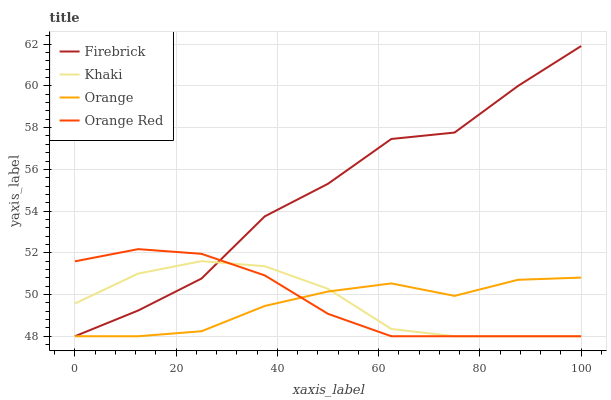Does Orange have the minimum area under the curve?
Answer yes or no. Yes. Does Firebrick have the maximum area under the curve?
Answer yes or no. Yes. Does Khaki have the minimum area under the curve?
Answer yes or no. No. Does Khaki have the maximum area under the curve?
Answer yes or no. No. Is Orange Red the smoothest?
Answer yes or no. Yes. Is Firebrick the roughest?
Answer yes or no. Yes. Is Khaki the smoothest?
Answer yes or no. No. Is Khaki the roughest?
Answer yes or no. No. Does Orange have the lowest value?
Answer yes or no. Yes. Does Firebrick have the highest value?
Answer yes or no. Yes. Does Khaki have the highest value?
Answer yes or no. No. Does Firebrick intersect Orange?
Answer yes or no. Yes. Is Firebrick less than Orange?
Answer yes or no. No. Is Firebrick greater than Orange?
Answer yes or no. No. 